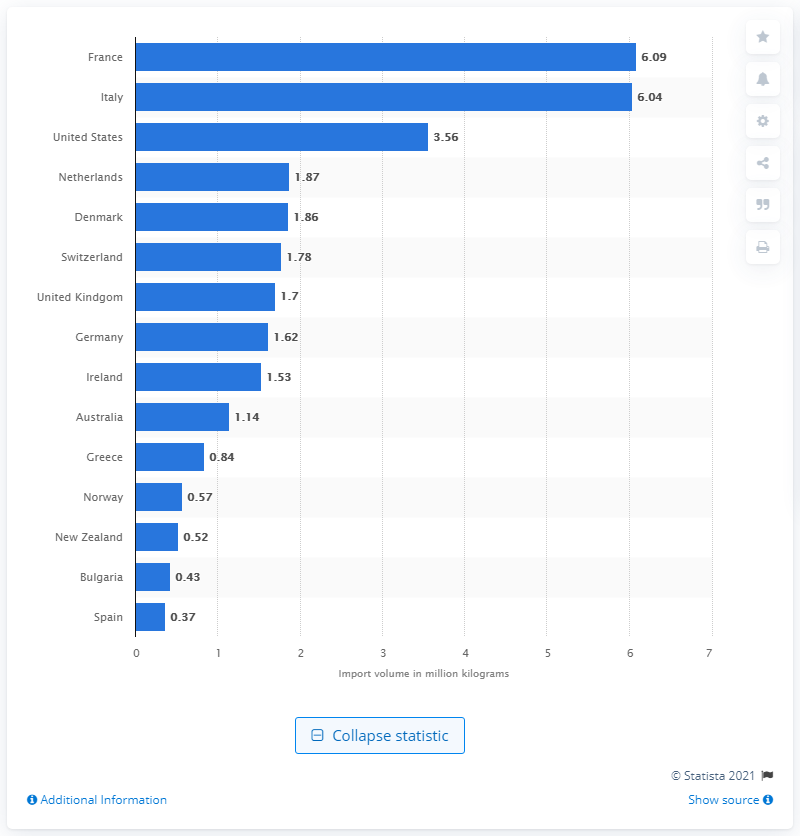Specify some key components in this picture. In 2019, Italy was the country that exported the largest amount of cheese to Canada. In 2019, France exported 6,090 metric tons of cheese to Canada. 